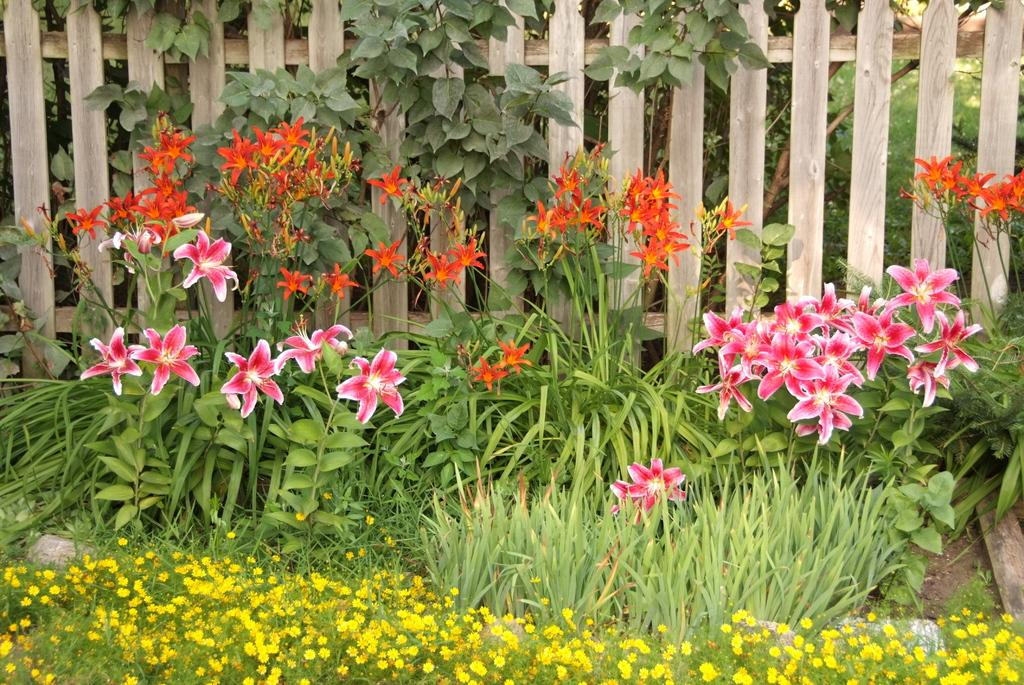What type of living organisms can be seen in the image? There are flowers in the image. What are the flowers growing on? The flowers are on plants. What colors can be observed in the flowers? The flowers are in pink, white, orange, and yellow colors. What type of material is the fence in the image made of? There is a wooden fence in the image. What territory is being claimed by the flowers in the image? The flowers in the image are not claiming any territory; they are simply growing on plants. 